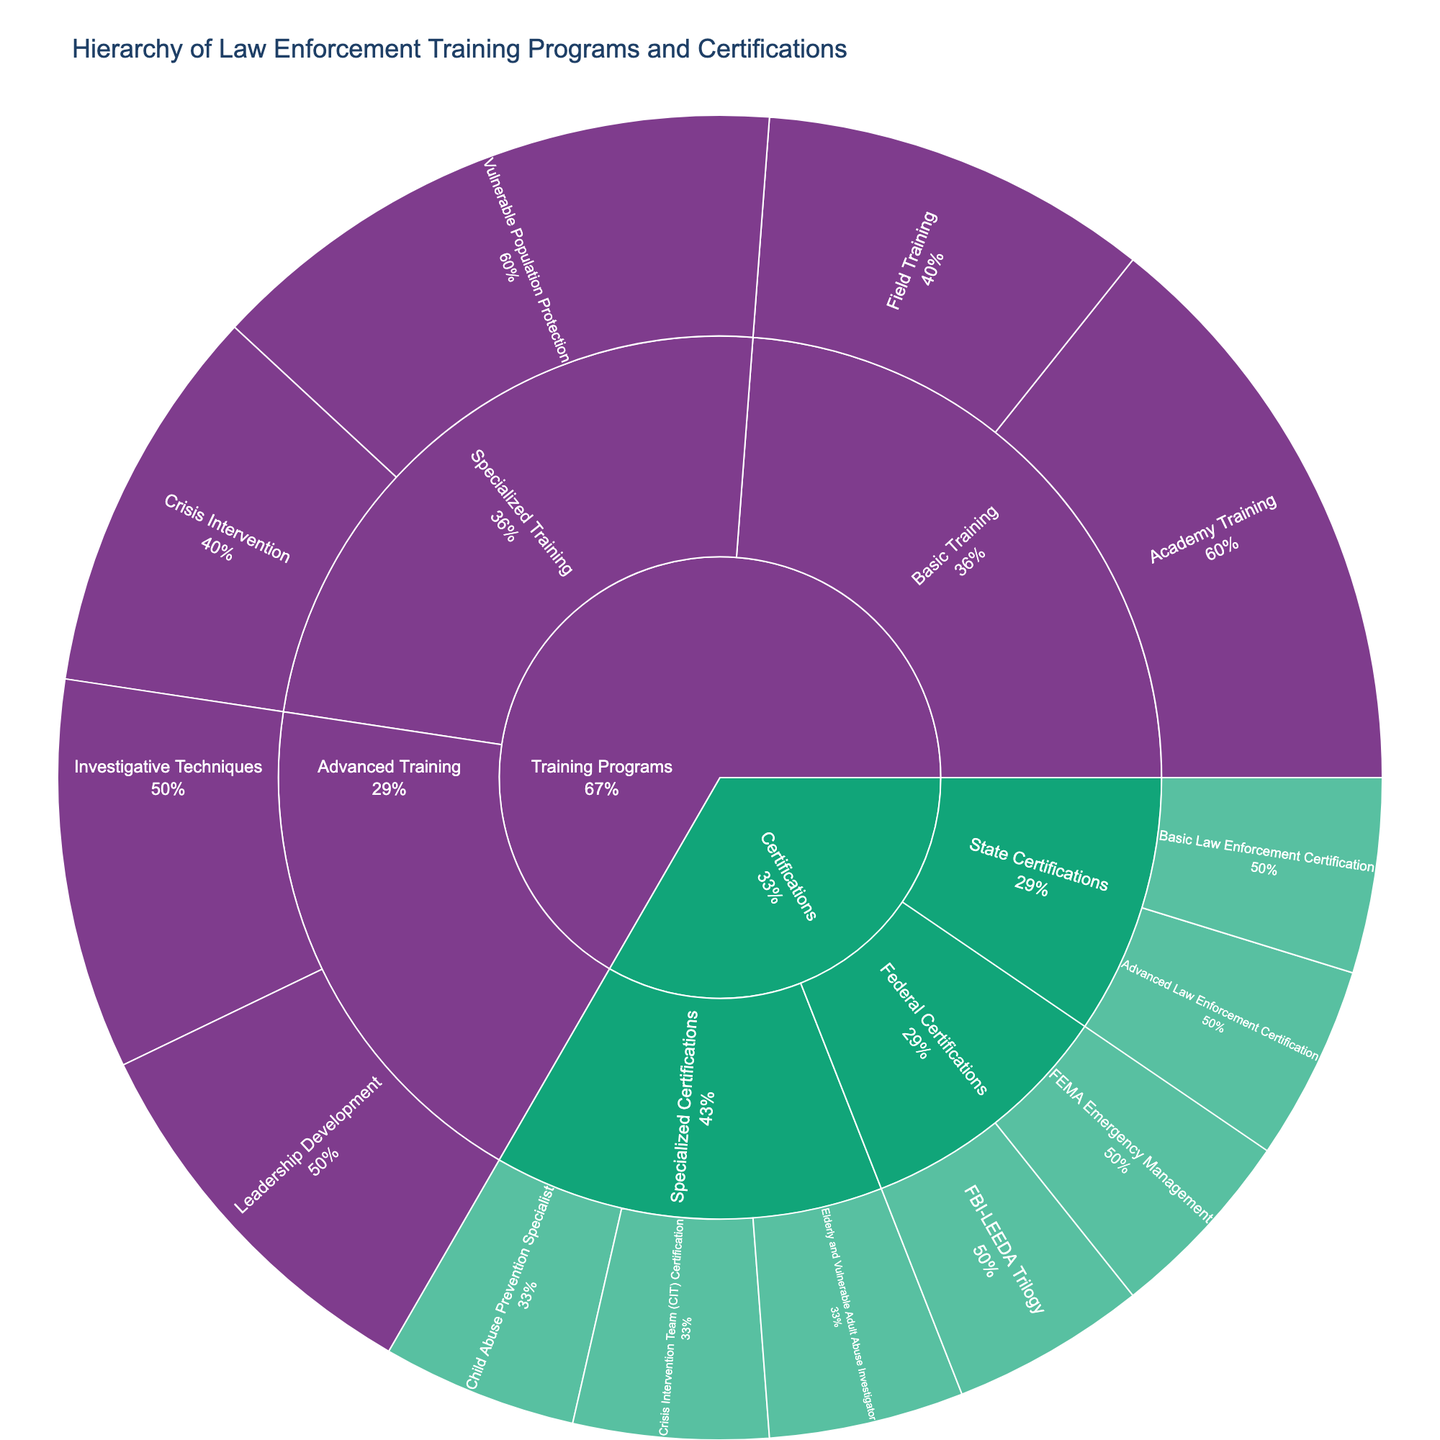what is the main title of the plot? The figure has a main title that describes the content and purpose of the plot. By looking at the top of the figure, you can see it clearly labeled.
Answer: Hierarchy of Law Enforcement Training Programs and Certifications How many categories are directly under the root level "Training Programs"? By focusing on the structure of the sunburst plot, you can see the immediate segments branching out from the root labeled "Training Programs". Count these segments.
Answer: 3 Which certification is specific for dealing with vulnerable adults? Look at the segment under the "Certifications" path, then under "Specialized Certifications" to identify certifications related to vulnerable adults.
Answer: Elderly and Vulnerable Adult Abuse Investigator How are "Community Policing" and "Patrol Procedures" related? Find both "Community Policing" and "Patrol Procedures" in the plot and trace their hierarchy levels to find their parent category.
Answer: They are both under "Field Training" What percentage of "Basic Training" is comprised of "Academy Training"? Since percentages are indicated by the sunburst, find the segment for "Academy Training" under "Basic Training" and look at the percentage value provided.
Answer: Varies Which training program deals with "Firearms Proficiency"? Find the "Firearms Proficiency" segment in the sunburst plot. Trace its hierarchy levels back to find the parent categories.
Answer: Academy Training How many segments deal directly with vulnerable population protection in training programs? Search for segments under "Specialized Training" with "Vulnerable Population Protection" then count how many segments branch out underneath it.
Answer: 3 Which root level category has more subcategories: "Training Programs" or "Certifications"? Compare the number of immediate subcategories branching out from both "Training Programs" and "Certifications" in the plot.
Answer: Training Programs What is the second level under "Advanced Training"? Find the main segment for "Advanced Training", then look at the segments one level down from it to identify the second-level categories.
Answer: Leadership Development, Investigative Techniques What certifications require Federal level approval? Identify segments under "Federal Certifications" to determine which certifications require federal-level approval.
Answer: FBI-LEEDA Trilogy, FEMA Emergency Management 